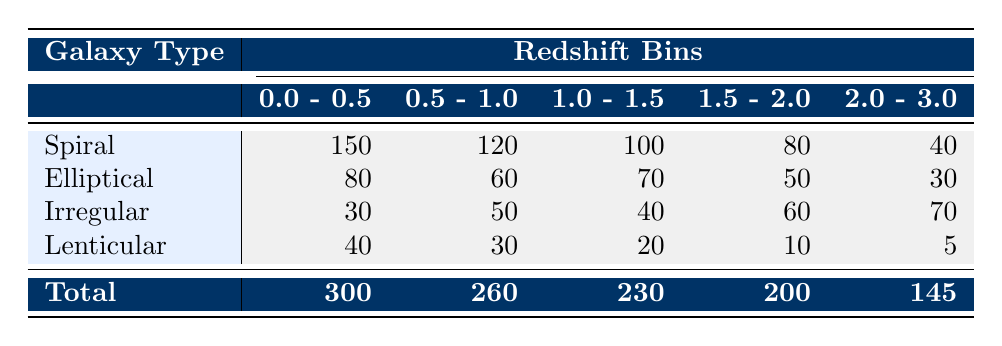What is the total number of galaxies in the redshift bin "0.0 - 0.5"? To find this, we need to look at the total row for the redshift bin "0.0 - 0.5". The total number of galaxies in this bin is provided as 300.
Answer: 300 Which galaxy type has the highest count in the redshift bin "1.5 - 2.0"? In the redshift bin "1.5 - 2.0", we compare the counts of each galaxy type: Spiral (80), Elliptical (50), Irregular (60), and Lenticular (10). Spiral has the highest count at 80.
Answer: Spiral What is the average number of Elliptical galaxies across all redshift bins? To calculate the average, we sum the counts of Elliptical galaxies: 80 + 60 + 70 + 50 + 30 = 290. There are 5 redshift bins, so the average is 290 / 5 = 58.
Answer: 58 Did the number of Spiral galaxies increase or decrease from the redshift bin "0.0 - 0.5" to "2.0 - 3.0"? The count for Spiral galaxies in the "0.0 - 0.5" bin is 150, and in the "2.0 - 3.0" bin, it is 40. Since 150 is greater than 40, it has decreased.
Answer: Decrease What is the difference in the number of Irregular galaxies between the bins "0.5 - 1.0" and "1.5 - 2.0"? The Irregular counts are 50 in the "0.5 - 1.0" bin and 60 in the "1.5 - 2.0" bin. To find the difference, we calculate 60 - 50 = 10.
Answer: 10 Which galaxy type has the least count in the redshift bin "2.0 - 3.0"? In the redshift bin "2.0 - 3.0", the galaxy counts are Spiral (40), Elliptical (30), Irregular (70), and Lenticular (5). The least count is for Lenticular, which has 5.
Answer: Lenticular What is the total number of Irregular galaxies across all redshift bins? We sum the counts of Irregular galaxies in each bin: 30 + 50 + 40 + 60 + 70 = 250. This gives us the total.
Answer: 250 Was the count of Lenticular galaxies greater in the bin "1.0 - 1.5" compared to "1.5 - 2.0"? The count for Lenticular galaxies in "1.0 - 1.5" is 20, and in "1.5 - 2.0" it is 10. Since 20 is greater than 10, the statement is true.
Answer: Yes What is the combined total of Spiral and Lenticular galaxies in the redshift bin "0.5 - 1.0"? The count of Spiral galaxies in this bin is 120 and Lenticular is 30. We add those up: 120 + 30 = 150.
Answer: 150 